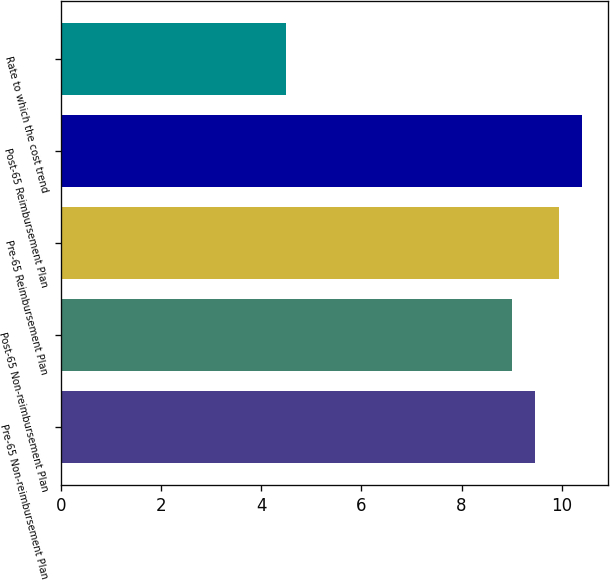Convert chart to OTSL. <chart><loc_0><loc_0><loc_500><loc_500><bar_chart><fcel>Pre-65 Non-reimbursement Plan<fcel>Post-65 Non-reimbursement Plan<fcel>Pre-65 Reimbursement Plan<fcel>Post-65 Reimbursement Plan<fcel>Rate to which the cost trend<nl><fcel>9.47<fcel>9<fcel>9.94<fcel>10.41<fcel>4.5<nl></chart> 